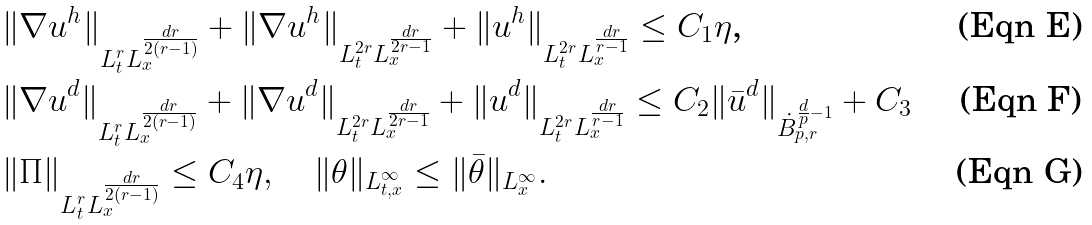<formula> <loc_0><loc_0><loc_500><loc_500>& \| \nabla u ^ { h } \| _ { L ^ { r } _ { t } L ^ { \frac { d r } { 2 ( r - 1 ) } } _ { x } } + \| \nabla u ^ { h } \| _ { L ^ { 2 r } _ { t } L ^ { \frac { d r } { 2 r - 1 } } _ { x } } + \| u ^ { h } \| _ { L ^ { 2 r } _ { t } L ^ { \frac { d r } { r - 1 } } _ { x } } \leq C _ { 1 } \eta \text {,} \\ & \| \nabla u ^ { d } \| _ { L ^ { r } _ { t } L ^ { \frac { d r } { 2 ( r - 1 ) } } _ { x } } + \| \nabla u ^ { d } \| _ { L ^ { 2 r } _ { t } L ^ { \frac { d r } { 2 r - 1 } } _ { x } } + \| u ^ { d } \| _ { L ^ { 2 r } _ { t } L ^ { \frac { d r } { r - 1 } } _ { x } } \leq C _ { 2 } \| \bar { u } ^ { d } \| _ { \dot { B } _ { p , r } ^ { \frac { d } { p } - 1 } } + C _ { 3 } \\ & \| \Pi \| _ { L ^ { r } _ { t } L ^ { \frac { d r } { 2 ( r - 1 ) } } _ { x } } \leq C _ { 4 } \eta , \quad \| \theta \| _ { L ^ { \infty } _ { t , x } } \leq \| \bar { \theta } \| _ { L ^ { \infty } _ { x } } .</formula> 